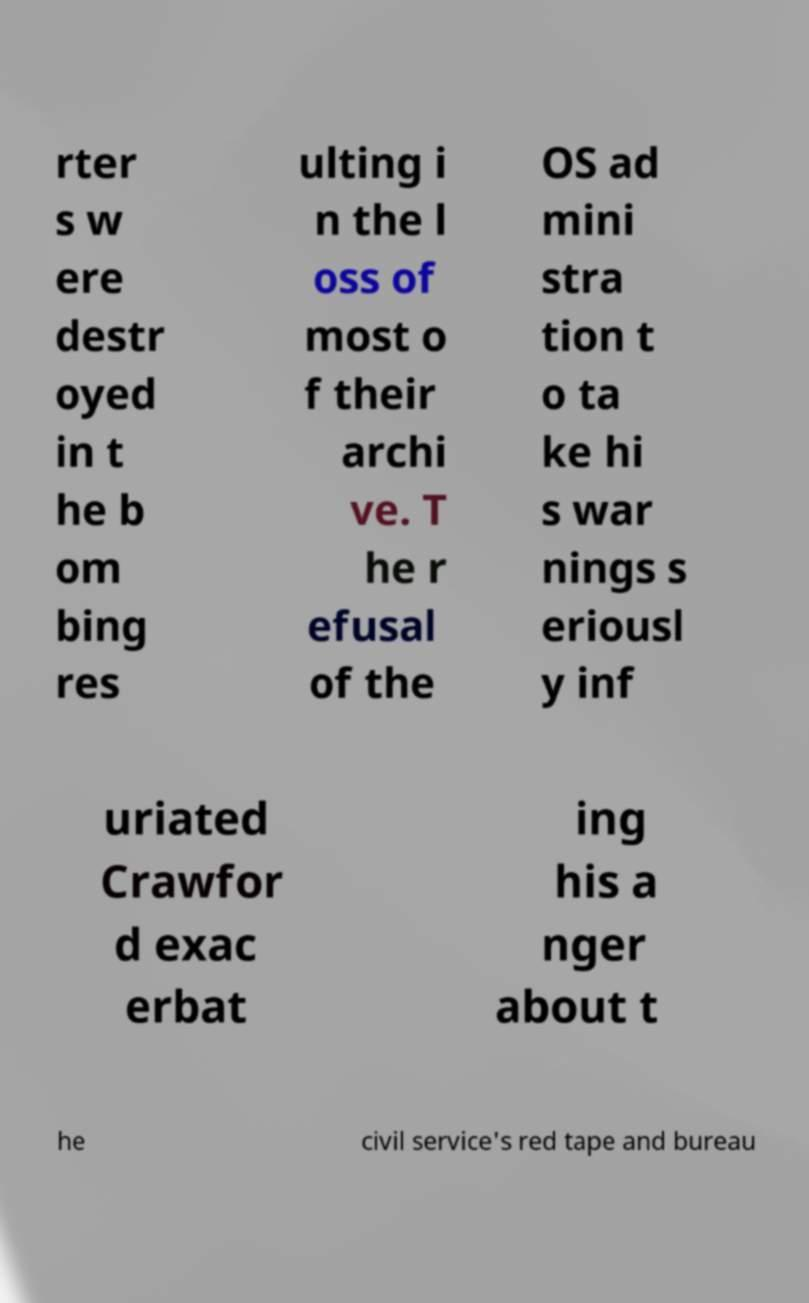Could you extract and type out the text from this image? rter s w ere destr oyed in t he b om bing res ulting i n the l oss of most o f their archi ve. T he r efusal of the OS ad mini stra tion t o ta ke hi s war nings s eriousl y inf uriated Crawfor d exac erbat ing his a nger about t he civil service's red tape and bureau 